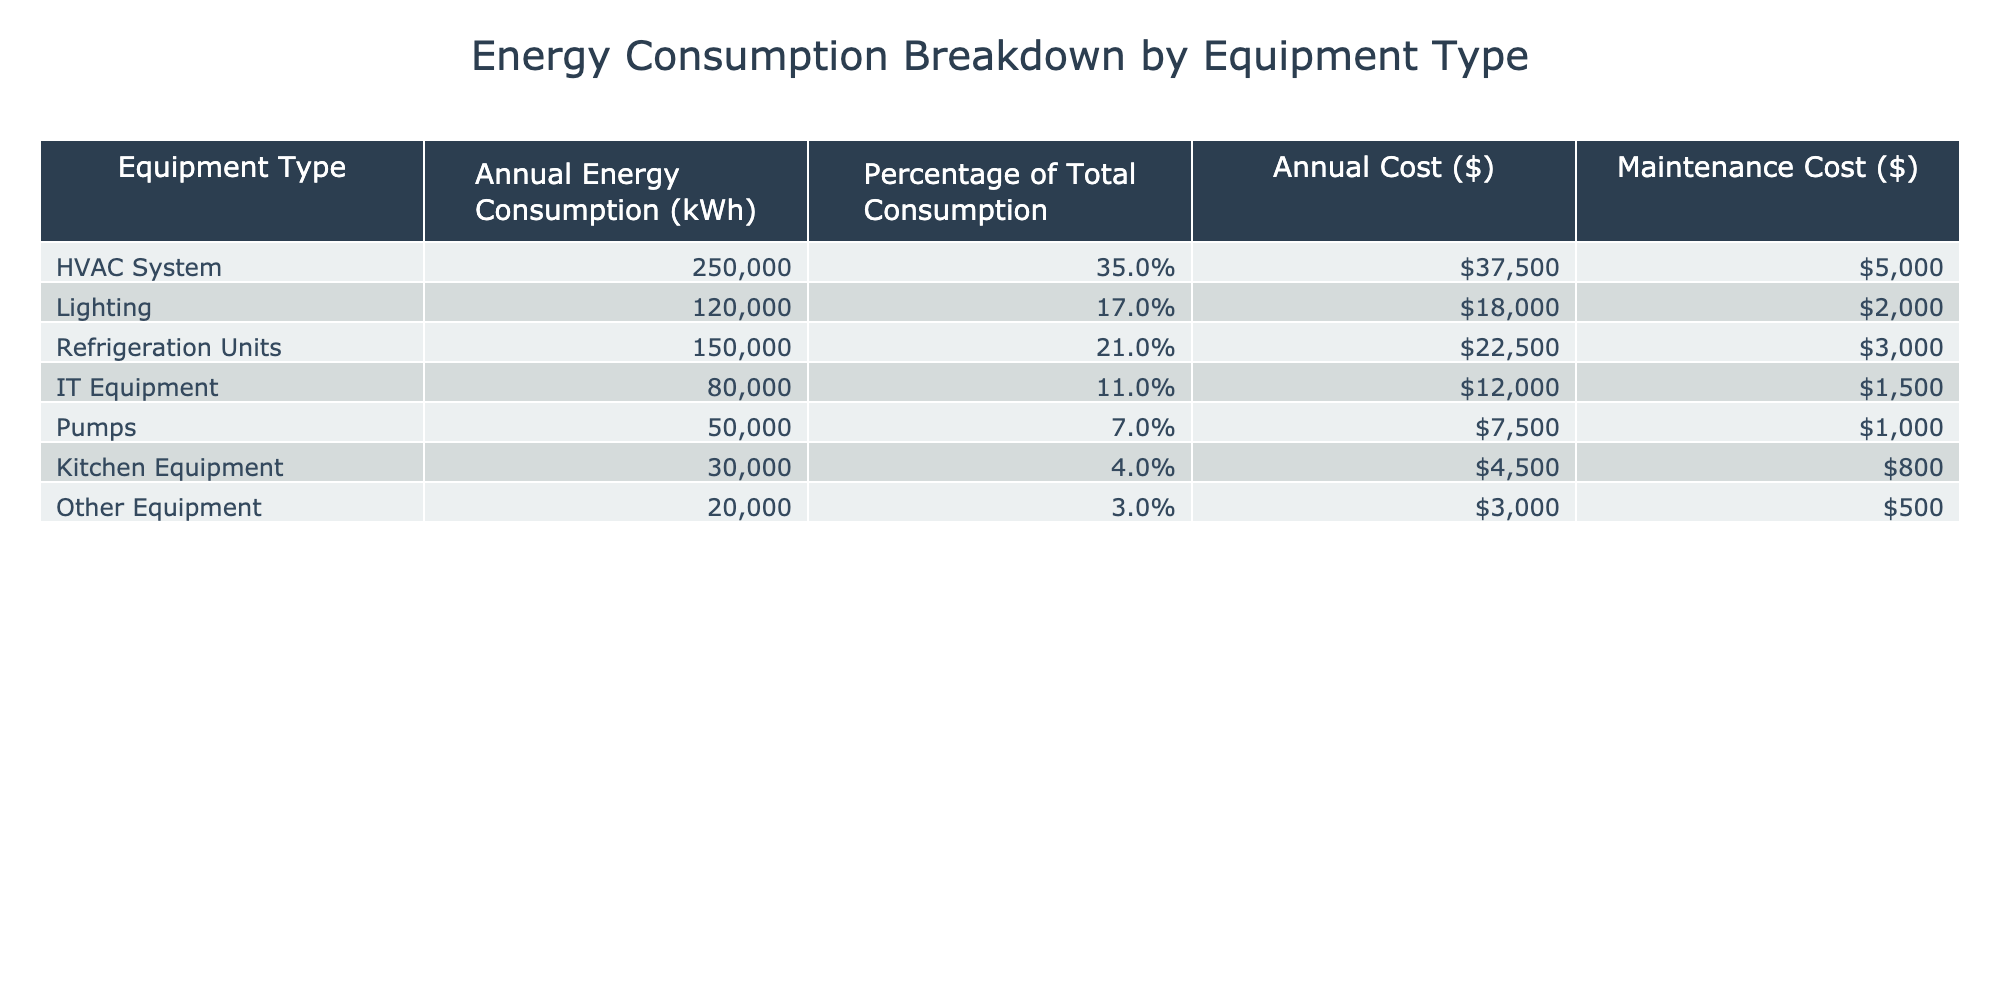What is the annual energy consumption of the HVAC System? The table lists the annual energy consumption for each equipment type. For the HVAC System, the corresponding value is 250,000 kWh.
Answer: 250,000 kWh Which equipment type has the lowest annual cost? The annual cost for each equipment type is provided in the table. The Kitchen Equipment has the lowest cost of $4,500.
Answer: $4,500 What percentage of total energy consumption is attributed to Lighting? The table shows that Lighting constitutes 17% of the total energy consumption. This value is directly stated in the table under the corresponding percentage column.
Answer: 17% What is the total annual energy consumption for Refrigeration Units and IT Equipment combined? The annual energy consumption for Refrigeration Units is 150,000 kWh, and for IT Equipment, it is 80,000 kWh. Adding these gives 150,000 + 80,000 = 230,000 kWh.
Answer: 230,000 kWh Is the total annual cost for Pumps over $10,000? The annual cost for Pumps shown in the table is $7,500. Since $7,500 is less than $10,000, the answer is no.
Answer: No Which equipment type consumes more energy: HVAC or Refrigeration Units? The table indicates that HVAC System consumes 250,000 kWh while Refrigeration Units consume 150,000 kWh. Since 250,000 kWh is greater than 150,000 kWh, HVAC consumes more energy.
Answer: HVAC System What is the average maintenance cost of all equipment types? The maintenance costs are provided as follows: HVAC System $5,000, Lighting $2,000, Refrigeration Units $3,000, IT Equipment $1,500, Pumps $1,000, Kitchen Equipment $800, and Other Equipment $500. Summing them gives a total of 13,800 and dividing by 7 (the number of equipment types) results in an average of approximately $1,971.43.
Answer: $1,971.43 What is the total percentage of energy consumption by IT Equipment and Pumps? The table shows that IT Equipment has a percentage of 11% and Pumps have 7%. Adding these percentages gives 11% + 7% = 18%.
Answer: 18% True or False: Kitchen Equipment has a higher annual cost than IT Equipment. The table indicates that Kitchen Equipment costs $4,500 while IT Equipment costs $12,000. Since $4,500 is less than $12,000, the statement is false.
Answer: False What is the annual cost of the HVAC System compared to its maintenance cost? The annual cost of the HVAC System is $37,500 while the maintenance cost is $5,000. Therefore, the HVAC System costs significantly more than its maintenance cost.
Answer: $37,500 